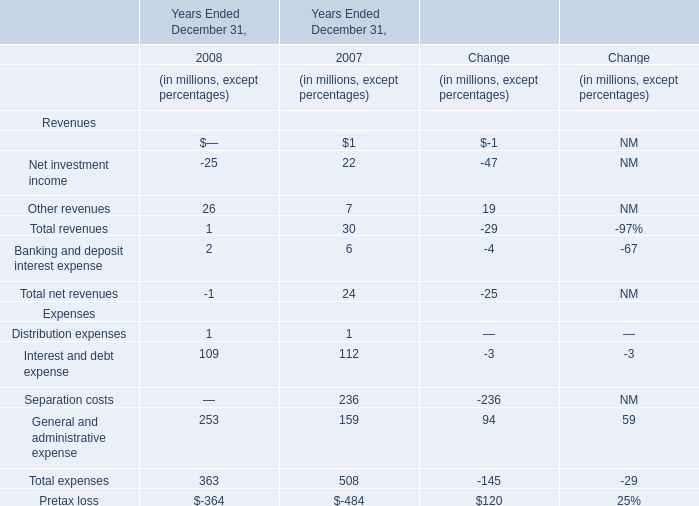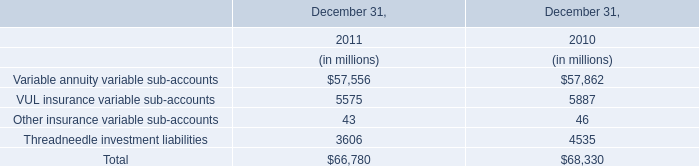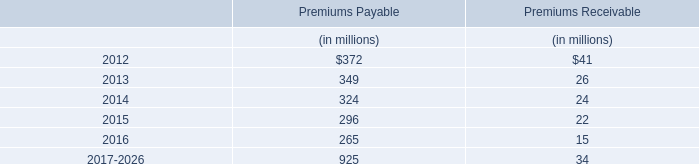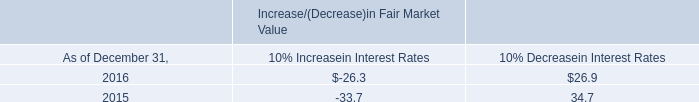Without Management and financial advice fees and Other revenues, how much of revenue is there in total in 2007 (in milion) 
Answer: 22. 